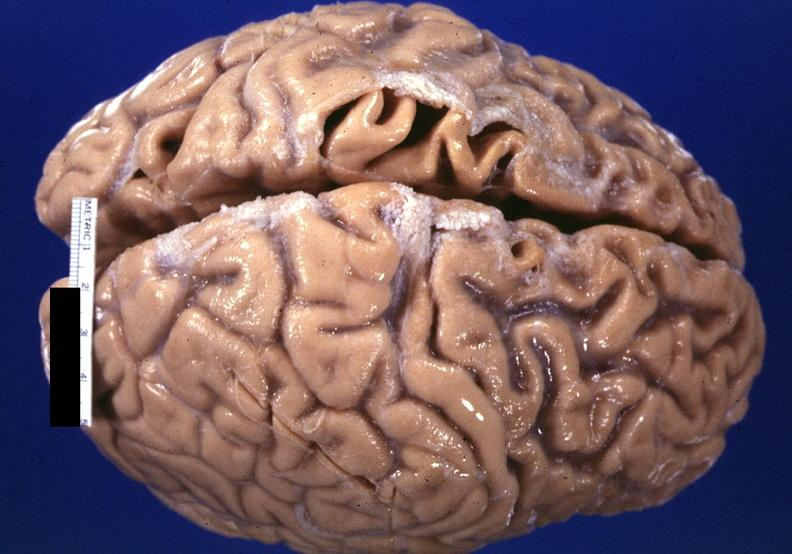what is present?
Answer the question using a single word or phrase. Nervous 